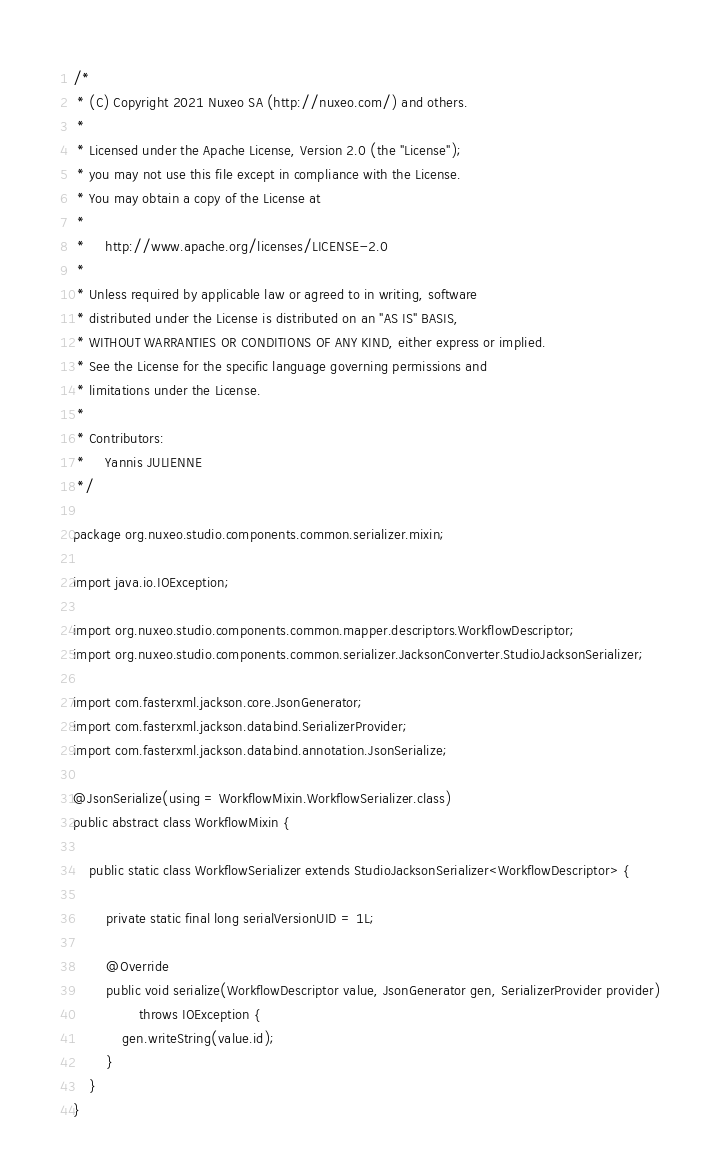<code> <loc_0><loc_0><loc_500><loc_500><_Java_>/*
 * (C) Copyright 2021 Nuxeo SA (http://nuxeo.com/) and others.
 *
 * Licensed under the Apache License, Version 2.0 (the "License");
 * you may not use this file except in compliance with the License.
 * You may obtain a copy of the License at
 *
 *     http://www.apache.org/licenses/LICENSE-2.0
 *
 * Unless required by applicable law or agreed to in writing, software
 * distributed under the License is distributed on an "AS IS" BASIS,
 * WITHOUT WARRANTIES OR CONDITIONS OF ANY KIND, either express or implied.
 * See the License for the specific language governing permissions and
 * limitations under the License.
 *
 * Contributors:
 *     Yannis JULIENNE
 */

package org.nuxeo.studio.components.common.serializer.mixin;

import java.io.IOException;

import org.nuxeo.studio.components.common.mapper.descriptors.WorkflowDescriptor;
import org.nuxeo.studio.components.common.serializer.JacksonConverter.StudioJacksonSerializer;

import com.fasterxml.jackson.core.JsonGenerator;
import com.fasterxml.jackson.databind.SerializerProvider;
import com.fasterxml.jackson.databind.annotation.JsonSerialize;

@JsonSerialize(using = WorkflowMixin.WorkflowSerializer.class)
public abstract class WorkflowMixin {

    public static class WorkflowSerializer extends StudioJacksonSerializer<WorkflowDescriptor> {

        private static final long serialVersionUID = 1L;

        @Override
        public void serialize(WorkflowDescriptor value, JsonGenerator gen, SerializerProvider provider)
                throws IOException {
            gen.writeString(value.id);
        }
    }
}
</code> 